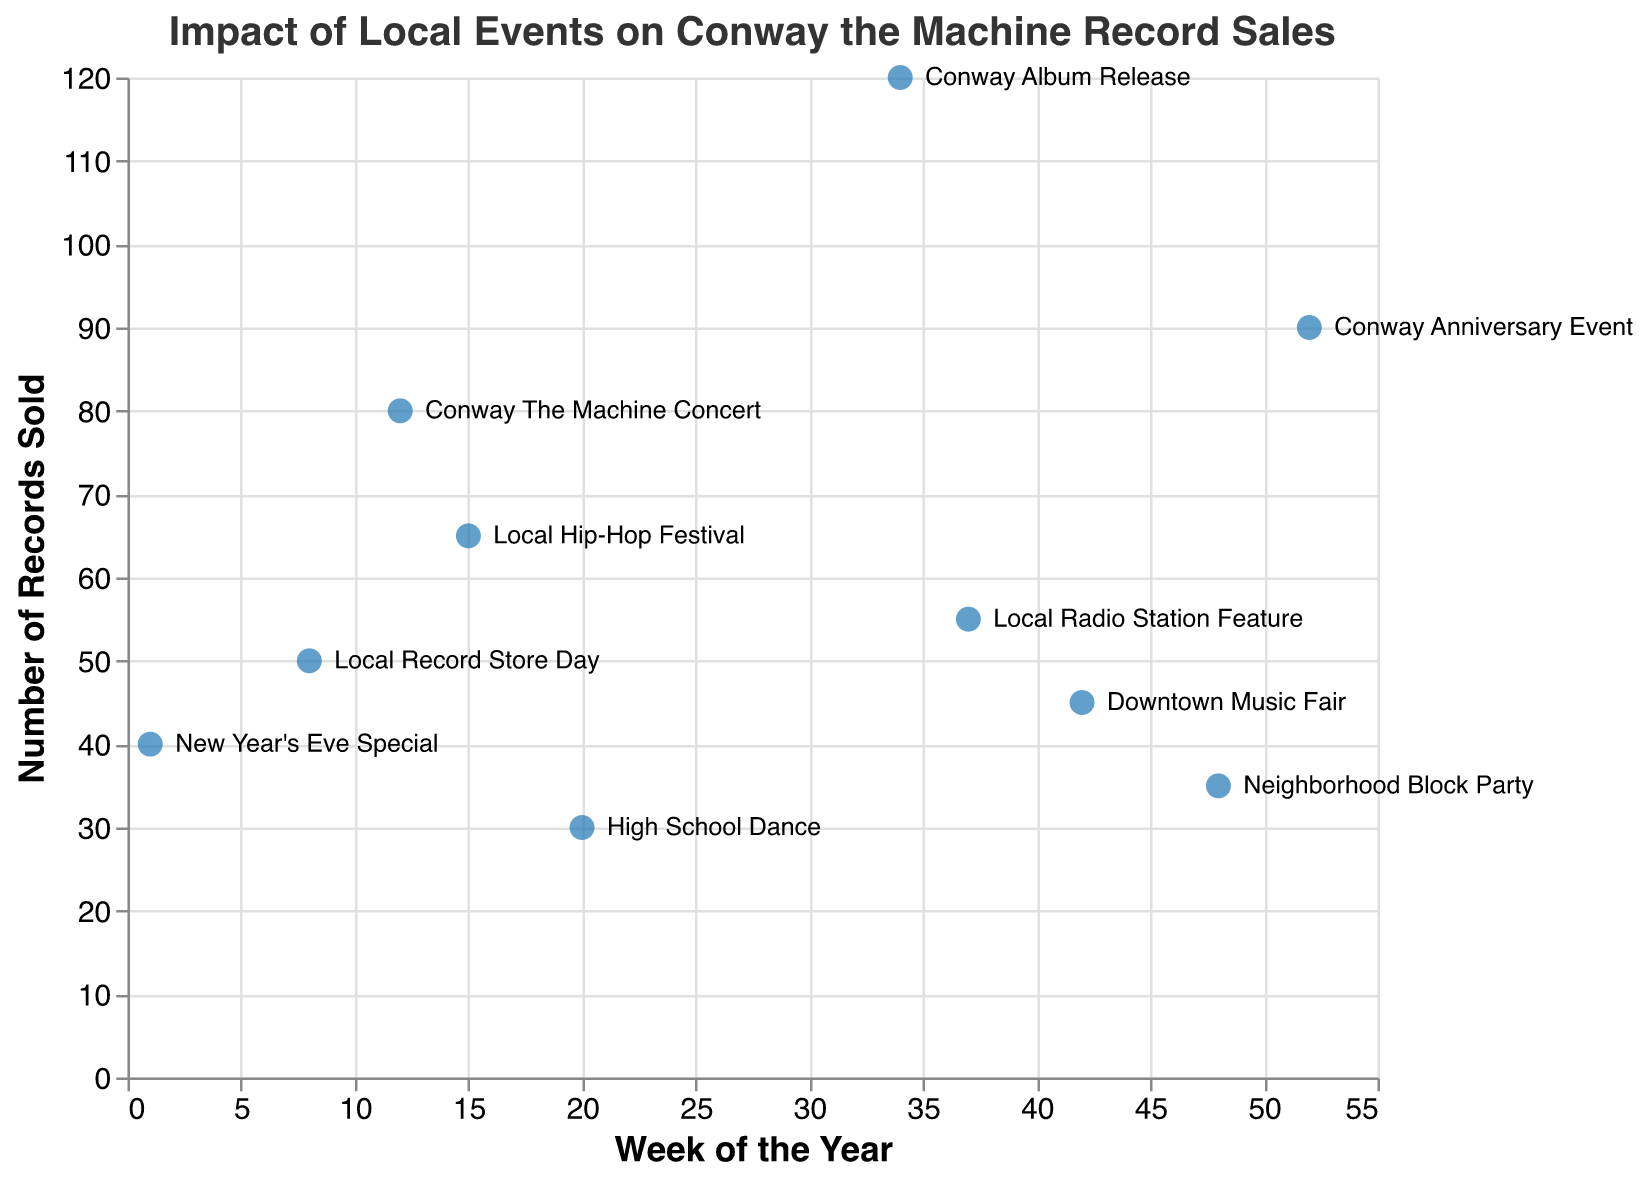What's the title of the figure? The title is written at the top of the plot and describes what the chart is about.
Answer: "Impact of Local Events on Conway the Machine Record Sales" What are the sales during the Conway Album Release? Identify the data point labeled "Conway Album Release" and read the corresponding "Sales" value.
Answer: 120 Which event resulted in the lowest sales, and how many records were sold? Find the event with the smallest "Sales" value and read the corresponding event name and sales number.
Answer: High School Dance, 30 How many weeks have events with sales greater than 50 records? Count the data points where the "Sales" value is greater than 50.
Answer: 6 Which week had a sales value of 90 records, and what was the event? Locate the data point with a "Sales" value of 90 and read the associated week and event name.
Answer: Week 52, Conway Anniversary Event What's the average number of records sold for events held from weeks 1 to 20? Sum the sales from relevant weeks (1, 8, 12, 15, 20) and divide by the number of events. \( \frac{40+50+80+65+30}{5} = 53 \)
Answer: 53 Did the New Year's Eve Special have higher or lower sales compared to Local Record Store Day? Compare the sales values for "New Year's Eve Special" (40) and "Local Record Store Day" (50).
Answer: Lower Which event caused the maximum increase in sales compared to the previous week, assuming no multiple events happened within a week? Calculate the difference in sales for each event compared to the previous event's sales, find the maximum difference.
Answer: Conway Album Release Are sales generally higher in the second half of the year (weeks 27-52) compared to the first half (weeks 1-26)? Calculate the average sales for weeks 1-26 and weeks 27-52 and compare the two values. \( \text{First half: } \frac{40+50+80+65+30}{5} = 53 \), \( \text{Second half: } \frac{120+55+45+35+90}{5} = 69 \)
Answer: Yes, higher in the second half 